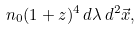<formula> <loc_0><loc_0><loc_500><loc_500>n _ { 0 } ( 1 + z ) ^ { 4 } \, d \lambda \, d ^ { 2 } \vec { x } ,</formula> 